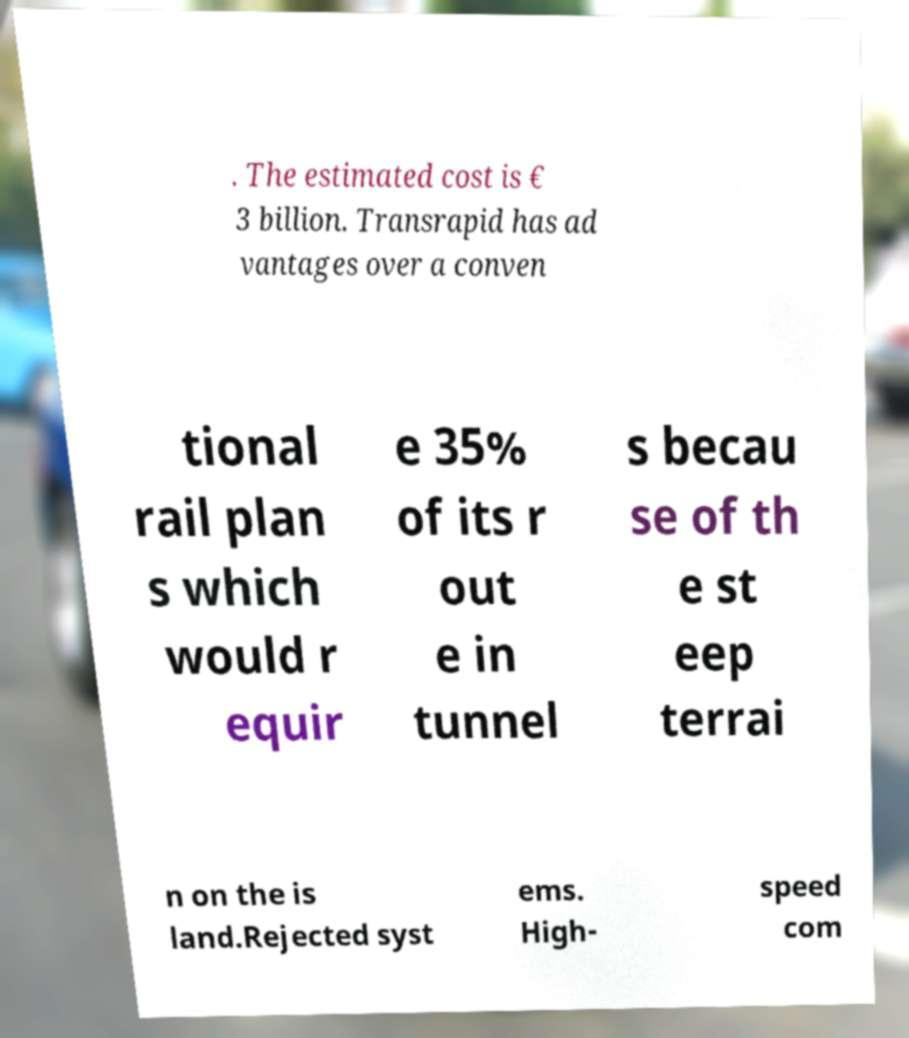Please identify and transcribe the text found in this image. . The estimated cost is € 3 billion. Transrapid has ad vantages over a conven tional rail plan s which would r equir e 35% of its r out e in tunnel s becau se of th e st eep terrai n on the is land.Rejected syst ems. High- speed com 